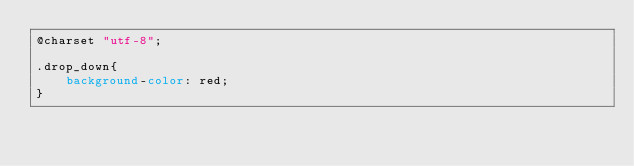<code> <loc_0><loc_0><loc_500><loc_500><_CSS_>@charset "utf-8";

.drop_down{
	background-color: red;
}</code> 